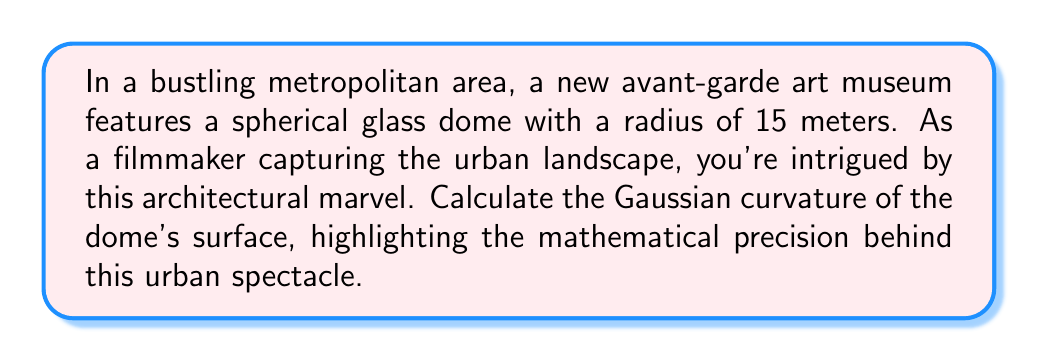Can you answer this question? To calculate the Gaussian curvature of a spherical dome, we'll follow these steps:

1) The Gaussian curvature (K) of a sphere is constant over its entire surface and is given by the formula:

   $$K = \frac{1}{R^2}$$

   where R is the radius of the sphere.

2) In this case, we're given that the radius of the dome is 15 meters.

3) Let's substitute this value into our formula:

   $$K = \frac{1}{(15\text{ m})^2}$$

4) Simplify:
   
   $$K = \frac{1}{225\text{ m}^2}$$

5) This can be further simplified to:

   $$K = \frac{1}{225}\text{ m}^{-2}$$

   or

   $$K \approx 0.004444\text{ m}^{-2}$$

The Gaussian curvature is a measure of how much the surface deviates from being flat. A positive value, as we have here, indicates that the surface curves in the same direction at every point, which is characteristic of a sphere or ellipsoid.

[asy]
import geometry;

size(200);
draw(circle((0,0),4));
draw((0,0)--(4,0),Arrow);
label("R",(2,0),S);
label("Spherical dome",(0,-5));
[/asy]

This positive curvature contributes to the dome's striking presence in the urban landscape, creating a focal point that contrasts with the typically flat or angular surfaces of surrounding buildings.
Answer: $$\frac{1}{225}\text{ m}^{-2}$$ 